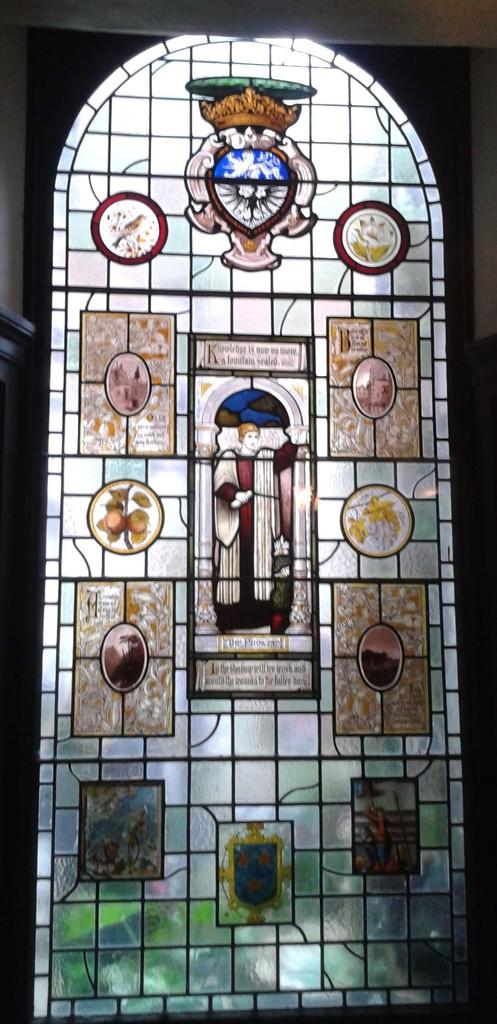What is present in the image that can be used for entering or exiting a space? There is a door in the image. Can you describe the appearance of the door? The door has a colorful design. What grade is the door designed for in the image? The image does not provide information about the grade or age group the door is designed for. 